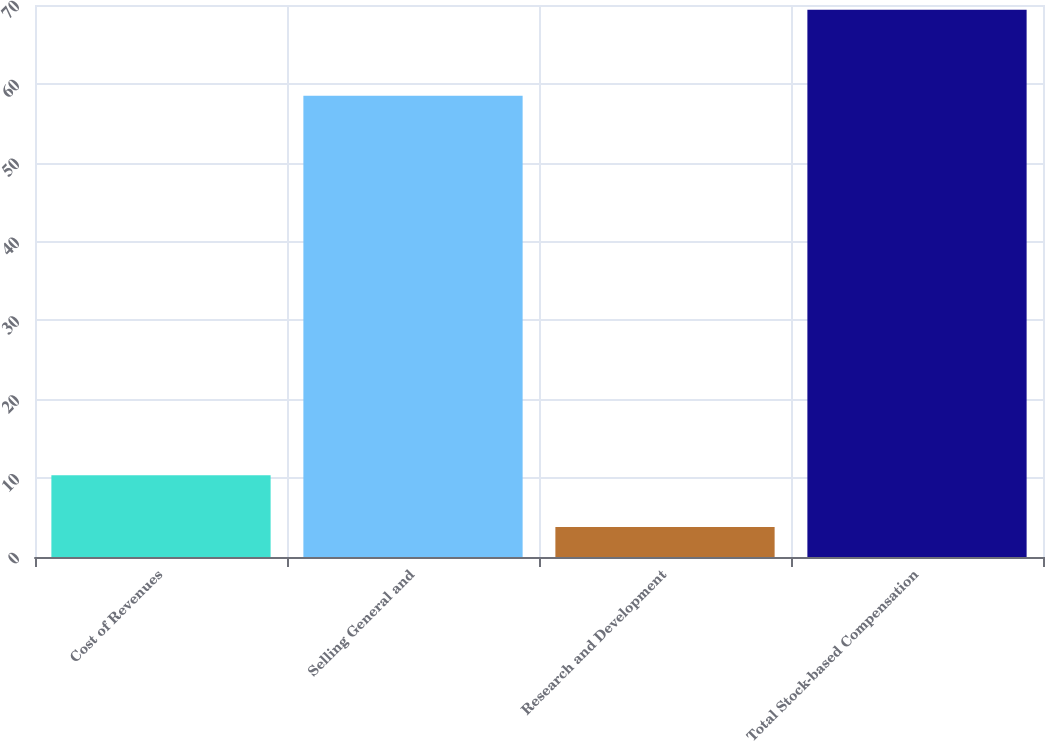Convert chart to OTSL. <chart><loc_0><loc_0><loc_500><loc_500><bar_chart><fcel>Cost of Revenues<fcel>Selling General and<fcel>Research and Development<fcel>Total Stock-based Compensation<nl><fcel>10.36<fcel>58.5<fcel>3.8<fcel>69.4<nl></chart> 